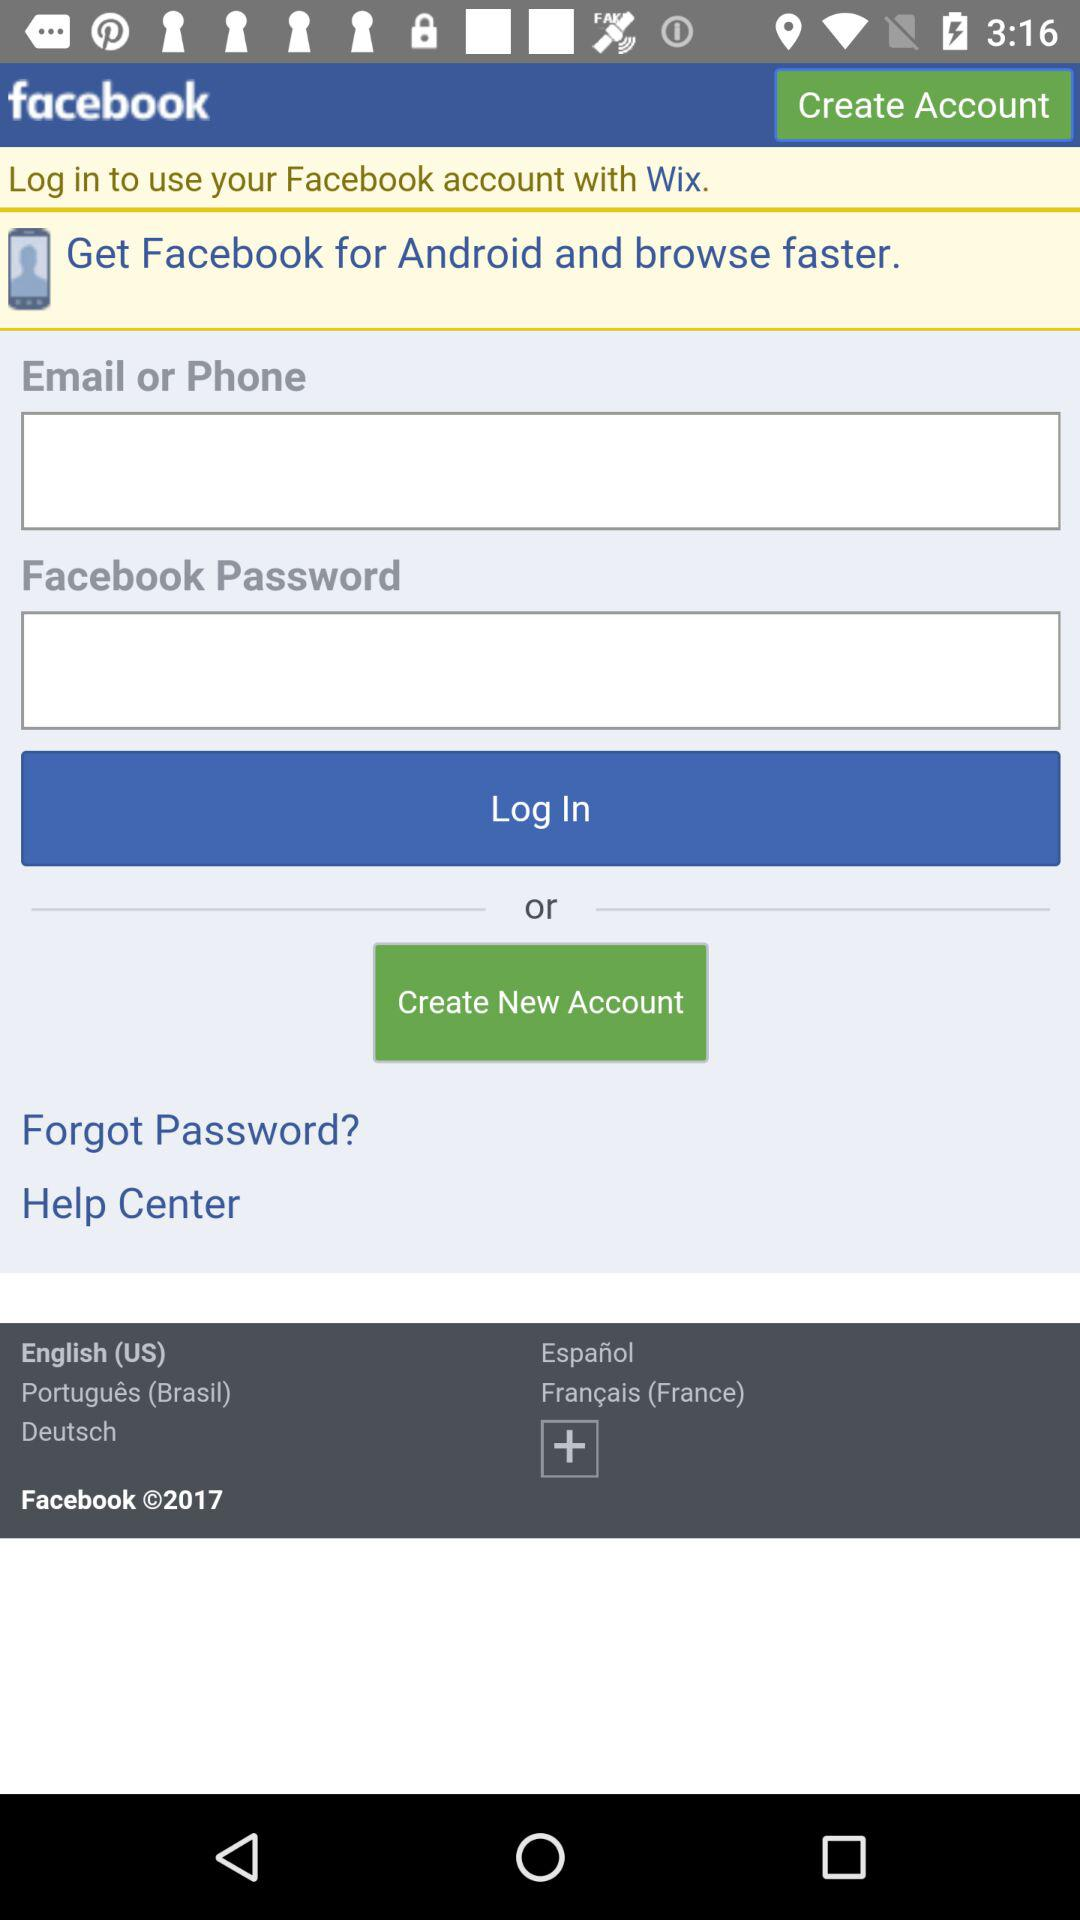What options for language are given other than English? The options for language are "Portugues (Brasil)", "Deutsch", "Espanol", and "Francais (France)". 